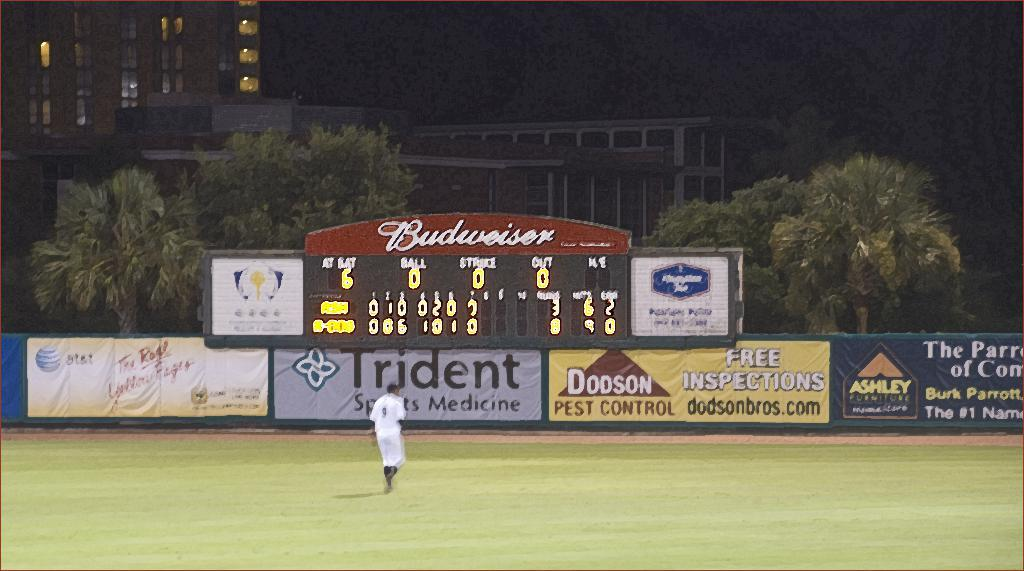Provide a one-sentence caption for the provided image. Dodson Pest Control is offering free inspections for people. 